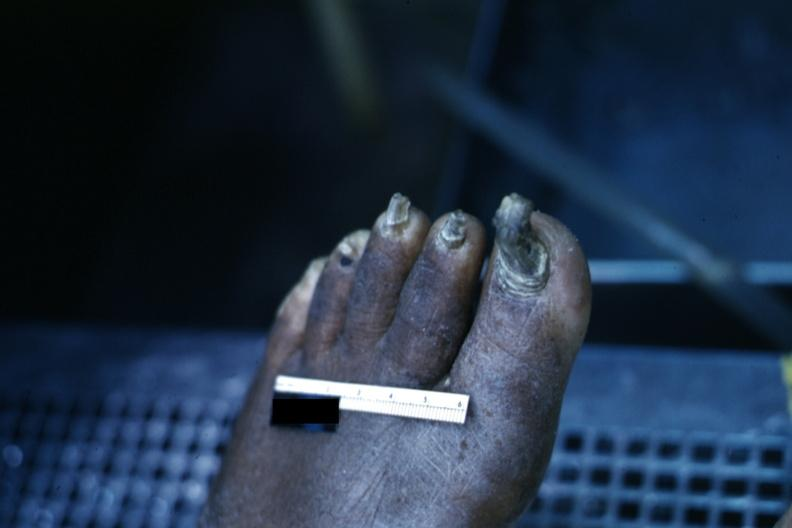what does this image show?
Answer the question using a single word or phrase. Distorted nails and thick skin typical of chronic ischemia 